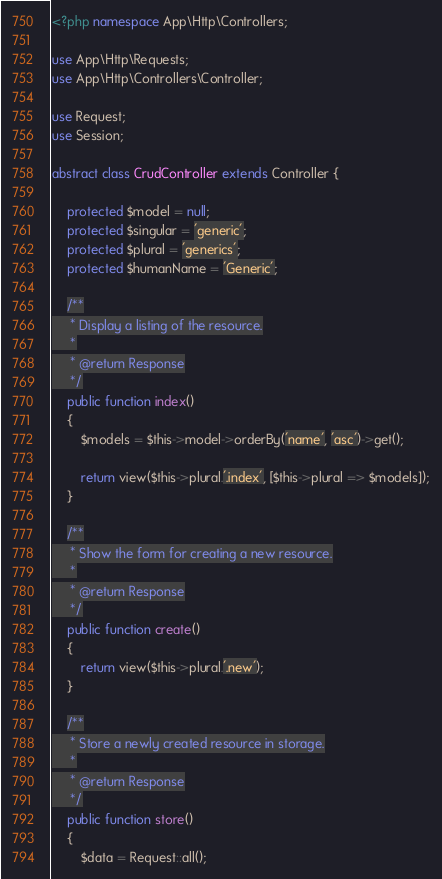<code> <loc_0><loc_0><loc_500><loc_500><_PHP_><?php namespace App\Http\Controllers;

use App\Http\Requests;
use App\Http\Controllers\Controller;

use Request;
use Session;

abstract class CrudController extends Controller {

    protected $model = null;
    protected $singular = 'generic';
    protected $plural = 'generics';
    protected $humanName = 'Generic';

	/**
	 * Display a listing of the resource.
	 *
	 * @return Response
	 */
	public function index()
	{
		$models = $this->model->orderBy('name', 'asc')->get();

        return view($this->plural.'.index', [$this->plural => $models]);
	}

	/**
	 * Show the form for creating a new resource.
	 *
	 * @return Response
	 */
	public function create()
	{
		return view($this->plural.'.new');
	}

	/**
	 * Store a newly created resource in storage.
	 *
	 * @return Response
	 */
	public function store()
	{
		$data = Request::all();
</code> 